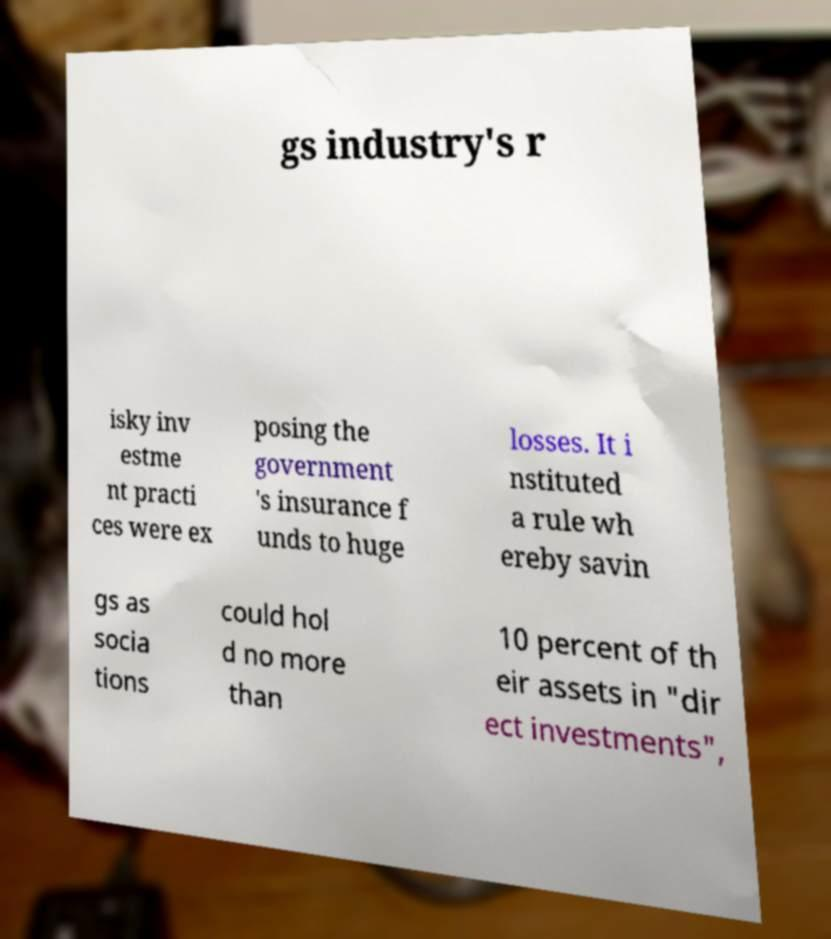Could you extract and type out the text from this image? gs industry's r isky inv estme nt practi ces were ex posing the government 's insurance f unds to huge losses. It i nstituted a rule wh ereby savin gs as socia tions could hol d no more than 10 percent of th eir assets in "dir ect investments", 